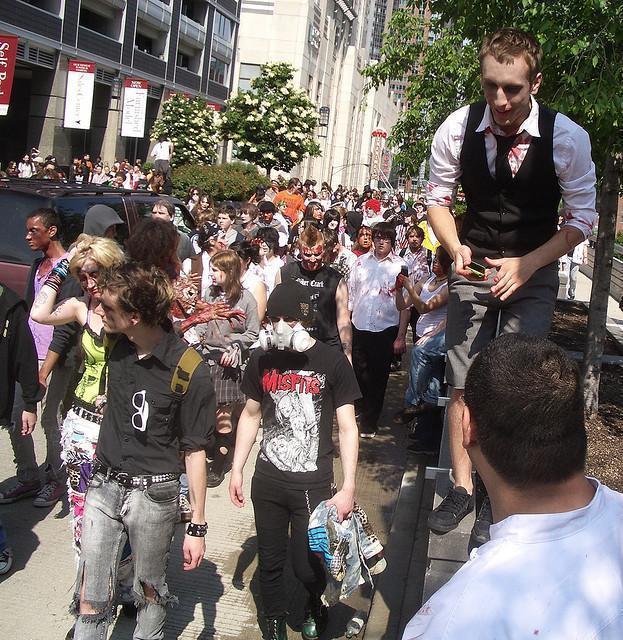The band on the shirt of the man wearing a mask belongs to what genre of music?
Choose the right answer from the provided options to respond to the question.
Options: Punk, country, hip hop, blues. Punk. 